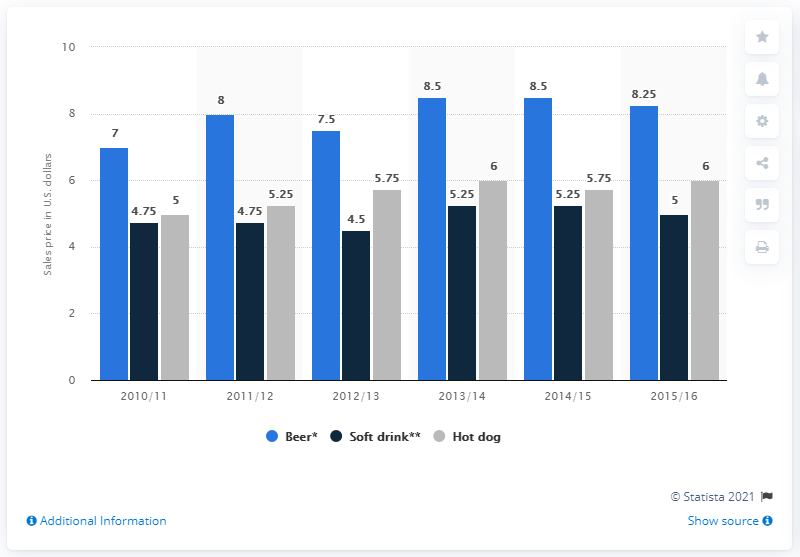Highlight a few significant elements in this photo. In 2013/14 and 2014/15, the stand prices for beer were the same. In the year 2015/16, the average of all three values was 6.4. 